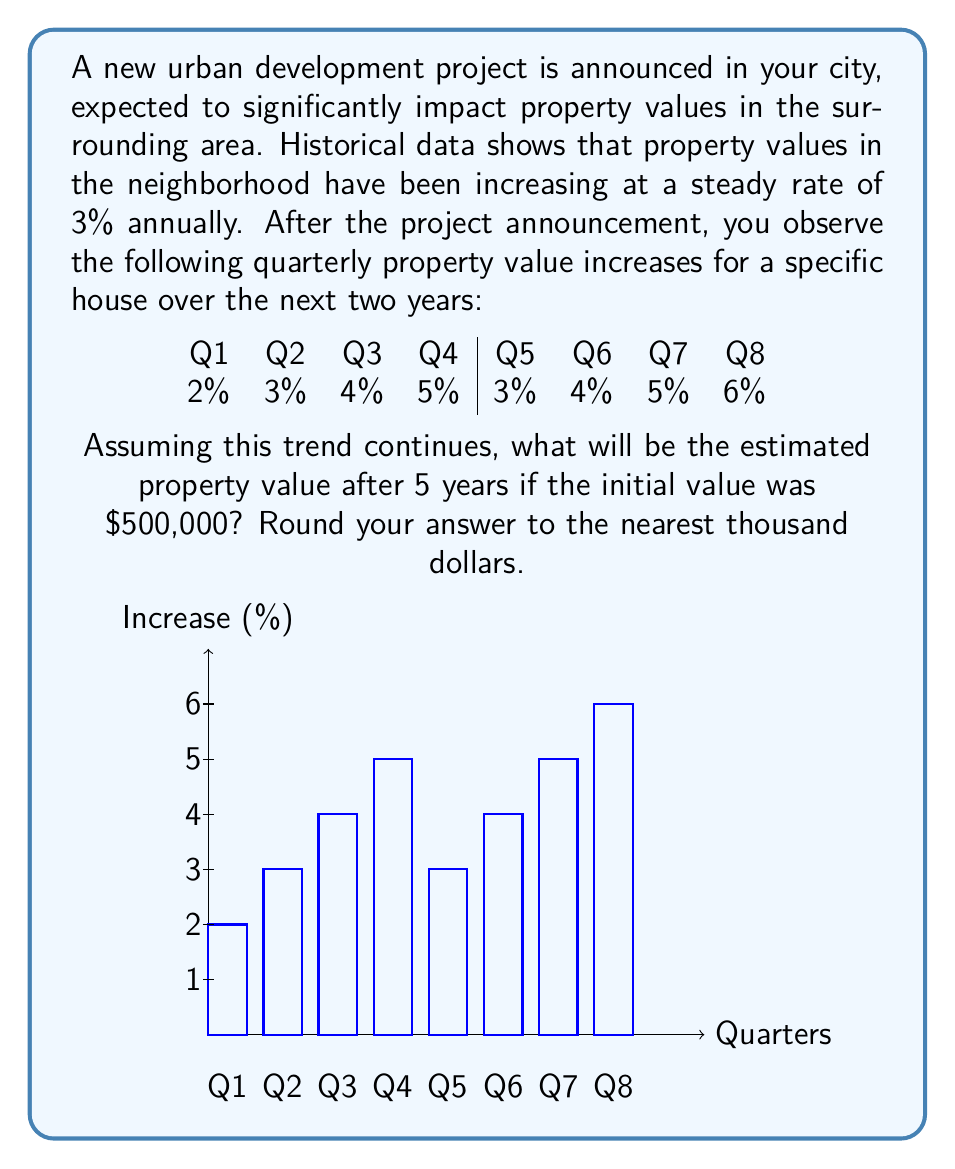Give your solution to this math problem. Let's approach this step-by-step:

1) First, we need to calculate the average quarterly growth rate from the given data:

   $\text{Average quarterly growth} = \frac{2\% + 3\% + 4\% + 5\% + 3\% + 4\% + 5\% + 6\%}{8} = 4\%$

2) To convert this to an annual growth rate, we compound it over 4 quarters:

   $\text{Annual growth rate} = (1 + 0.04)^4 - 1 = 1.1699 - 1 = 0.1699 = 16.99\%$

3) Now, we need to project this growth over 5 years. We use the compound interest formula:

   $FV = PV \times (1 + r)^n$

   Where:
   $FV$ = Future Value
   $PV$ = Present Value ($500,000)
   $r$ = Annual growth rate (0.1699)
   $n$ = Number of years (5)

4) Plugging in the values:

   $FV = 500,000 \times (1 + 0.1699)^5$

5) Calculate:

   $FV = 500,000 \times 2.1855 = 1,092,750$

6) Rounding to the nearest thousand:

   $FV \approx 1,093,000$
Answer: $1,093,000 